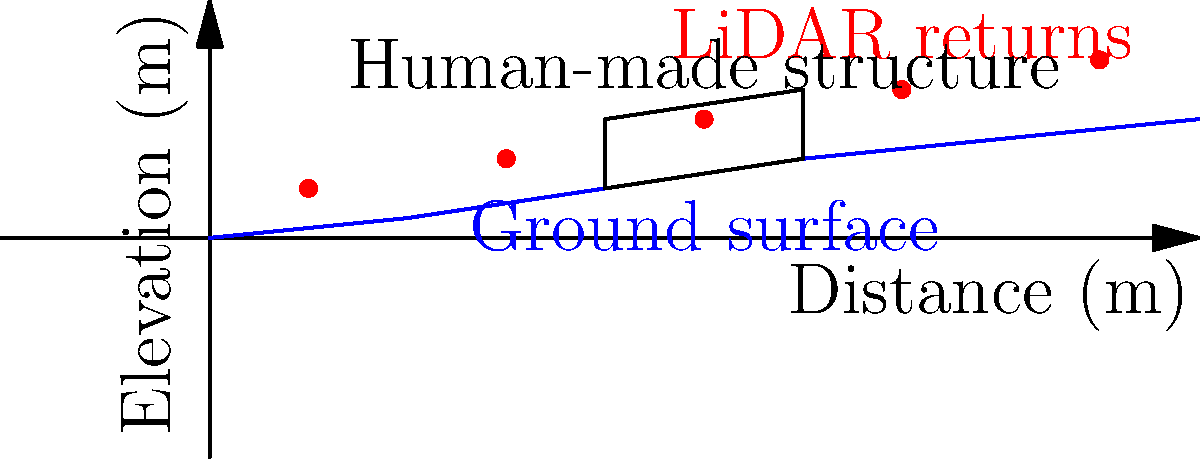In the LiDAR data visualization above, what characteristic of the human-made structure's LiDAR returns distinguishes it from the natural ground surface, and how might this aid in identifying artificial structures within national parks? To identify human-made structures in national parks using LiDAR data, we need to analyze the pattern of LiDAR returns:

1. Ground surface profile:
   - The blue line represents the natural ground surface.
   - It shows a gradual, smooth increase in elevation over distance.

2. LiDAR returns:
   - Red dots represent individual LiDAR returns.
   - They indicate the elevation at which the laser pulses were reflected.

3. Human-made structure:
   - The black outline represents an artificial structure.
   - LiDAR returns associated with this structure deviate from the ground surface pattern.

4. Key characteristic:
   - The LiDAR returns above the structure show an abrupt vertical displacement from the ground surface.
   - This creates a distinct "step" or "jump" in the elevation profile.

5. Natural vs. artificial features:
   - Natural features typically produce smooth, gradual changes in LiDAR return elevations.
   - Artificial structures often create sudden, sharp changes in elevation.

6. Identification method:
   - By detecting these abrupt vertical displacements in LiDAR data, researchers can identify potential human-made structures.
   - This method is particularly useful in national parks, where distinguishing between natural and artificial features is crucial for conservation and management.

7. Applications:
   - This technique can help in identifying unauthorized constructions, monitoring historical structures, or assessing human impact on protected areas.

The key characteristic that distinguishes the human-made structure is the abrupt vertical displacement of LiDAR returns, creating a sharp "step" in the elevation profile.
Answer: Abrupt vertical displacement in LiDAR returns 